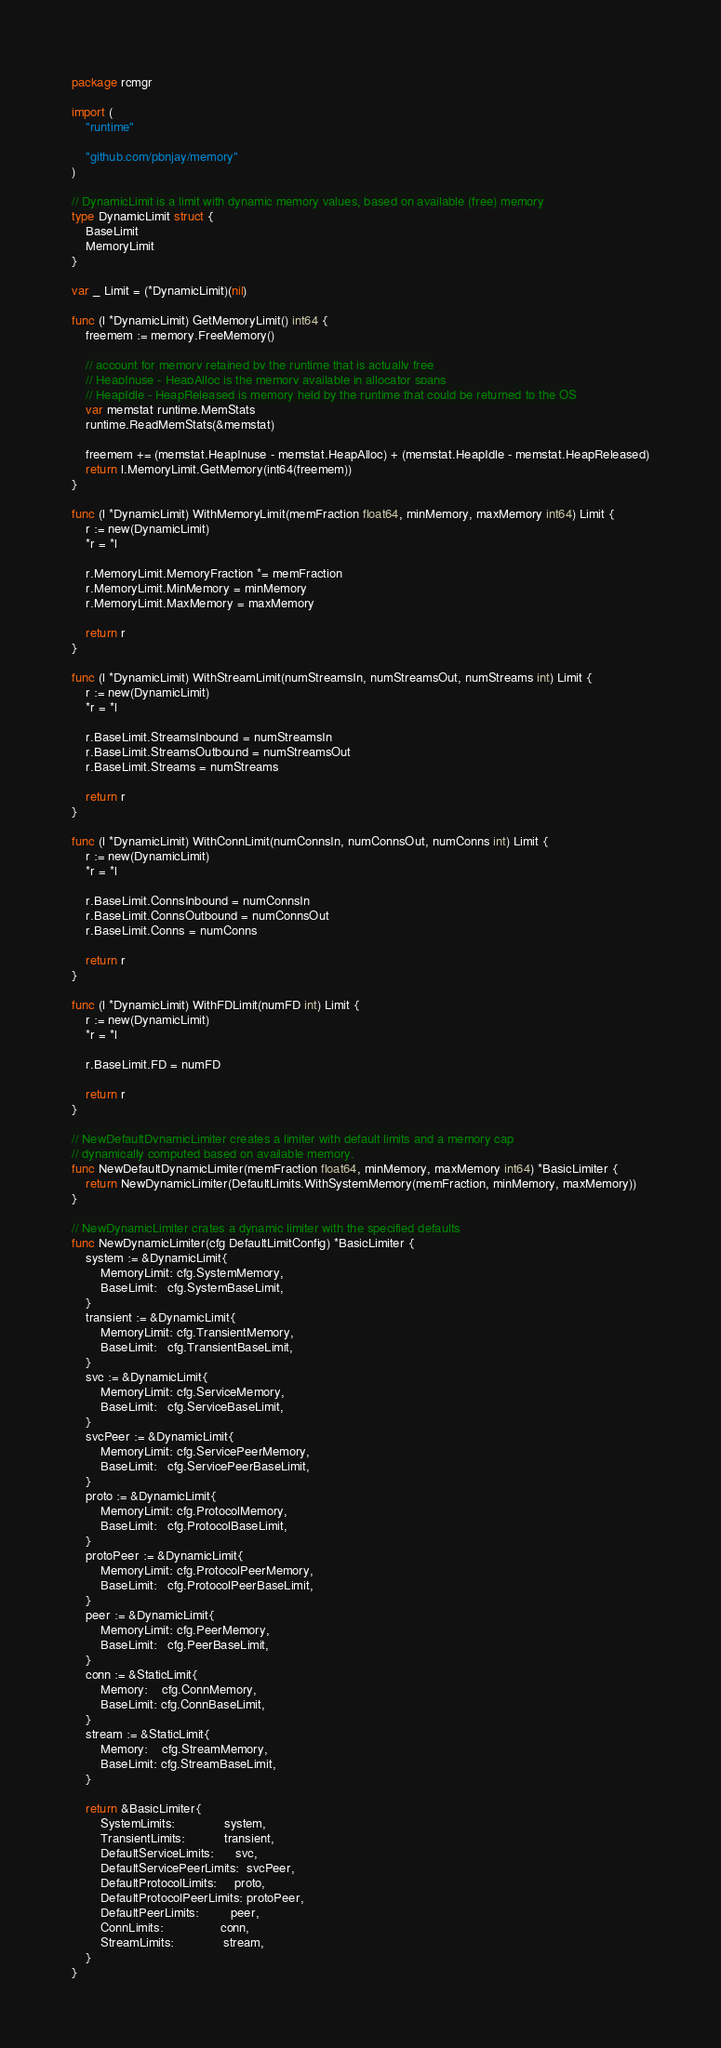Convert code to text. <code><loc_0><loc_0><loc_500><loc_500><_Go_>package rcmgr

import (
	"runtime"

	"github.com/pbnjay/memory"
)

// DynamicLimit is a limit with dynamic memory values, based on available (free) memory
type DynamicLimit struct {
	BaseLimit
	MemoryLimit
}

var _ Limit = (*DynamicLimit)(nil)

func (l *DynamicLimit) GetMemoryLimit() int64 {
	freemem := memory.FreeMemory()

	// account for memory retained by the runtime that is actually free
	// HeapInuse - HeapAlloc is the memory available in allocator spans
	// HeapIdle - HeapReleased is memory held by the runtime that could be returned to the OS
	var memstat runtime.MemStats
	runtime.ReadMemStats(&memstat)

	freemem += (memstat.HeapInuse - memstat.HeapAlloc) + (memstat.HeapIdle - memstat.HeapReleased)
	return l.MemoryLimit.GetMemory(int64(freemem))
}

func (l *DynamicLimit) WithMemoryLimit(memFraction float64, minMemory, maxMemory int64) Limit {
	r := new(DynamicLimit)
	*r = *l

	r.MemoryLimit.MemoryFraction *= memFraction
	r.MemoryLimit.MinMemory = minMemory
	r.MemoryLimit.MaxMemory = maxMemory

	return r
}

func (l *DynamicLimit) WithStreamLimit(numStreamsIn, numStreamsOut, numStreams int) Limit {
	r := new(DynamicLimit)
	*r = *l

	r.BaseLimit.StreamsInbound = numStreamsIn
	r.BaseLimit.StreamsOutbound = numStreamsOut
	r.BaseLimit.Streams = numStreams

	return r
}

func (l *DynamicLimit) WithConnLimit(numConnsIn, numConnsOut, numConns int) Limit {
	r := new(DynamicLimit)
	*r = *l

	r.BaseLimit.ConnsInbound = numConnsIn
	r.BaseLimit.ConnsOutbound = numConnsOut
	r.BaseLimit.Conns = numConns

	return r
}

func (l *DynamicLimit) WithFDLimit(numFD int) Limit {
	r := new(DynamicLimit)
	*r = *l

	r.BaseLimit.FD = numFD

	return r
}

// NewDefaultDynamicLimiter creates a limiter with default limits and a memory cap
// dynamically computed based on available memory.
func NewDefaultDynamicLimiter(memFraction float64, minMemory, maxMemory int64) *BasicLimiter {
	return NewDynamicLimiter(DefaultLimits.WithSystemMemory(memFraction, minMemory, maxMemory))
}

// NewDynamicLimiter crates a dynamic limiter with the specified defaults
func NewDynamicLimiter(cfg DefaultLimitConfig) *BasicLimiter {
	system := &DynamicLimit{
		MemoryLimit: cfg.SystemMemory,
		BaseLimit:   cfg.SystemBaseLimit,
	}
	transient := &DynamicLimit{
		MemoryLimit: cfg.TransientMemory,
		BaseLimit:   cfg.TransientBaseLimit,
	}
	svc := &DynamicLimit{
		MemoryLimit: cfg.ServiceMemory,
		BaseLimit:   cfg.ServiceBaseLimit,
	}
	svcPeer := &DynamicLimit{
		MemoryLimit: cfg.ServicePeerMemory,
		BaseLimit:   cfg.ServicePeerBaseLimit,
	}
	proto := &DynamicLimit{
		MemoryLimit: cfg.ProtocolMemory,
		BaseLimit:   cfg.ProtocolBaseLimit,
	}
	protoPeer := &DynamicLimit{
		MemoryLimit: cfg.ProtocolPeerMemory,
		BaseLimit:   cfg.ProtocolPeerBaseLimit,
	}
	peer := &DynamicLimit{
		MemoryLimit: cfg.PeerMemory,
		BaseLimit:   cfg.PeerBaseLimit,
	}
	conn := &StaticLimit{
		Memory:    cfg.ConnMemory,
		BaseLimit: cfg.ConnBaseLimit,
	}
	stream := &StaticLimit{
		Memory:    cfg.StreamMemory,
		BaseLimit: cfg.StreamBaseLimit,
	}

	return &BasicLimiter{
		SystemLimits:              system,
		TransientLimits:           transient,
		DefaultServiceLimits:      svc,
		DefaultServicePeerLimits:  svcPeer,
		DefaultProtocolLimits:     proto,
		DefaultProtocolPeerLimits: protoPeer,
		DefaultPeerLimits:         peer,
		ConnLimits:                conn,
		StreamLimits:              stream,
	}
}
</code> 